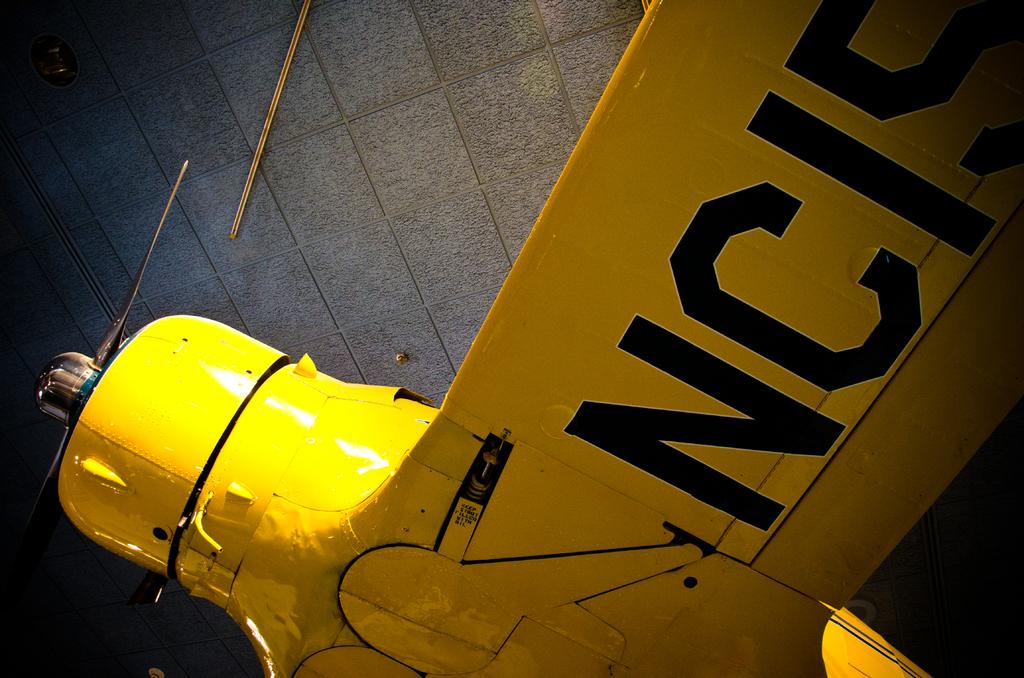What do the black letters say?
Keep it short and to the point. Nc15. What are the two numbers after the two letters?
Offer a terse response. 15. 